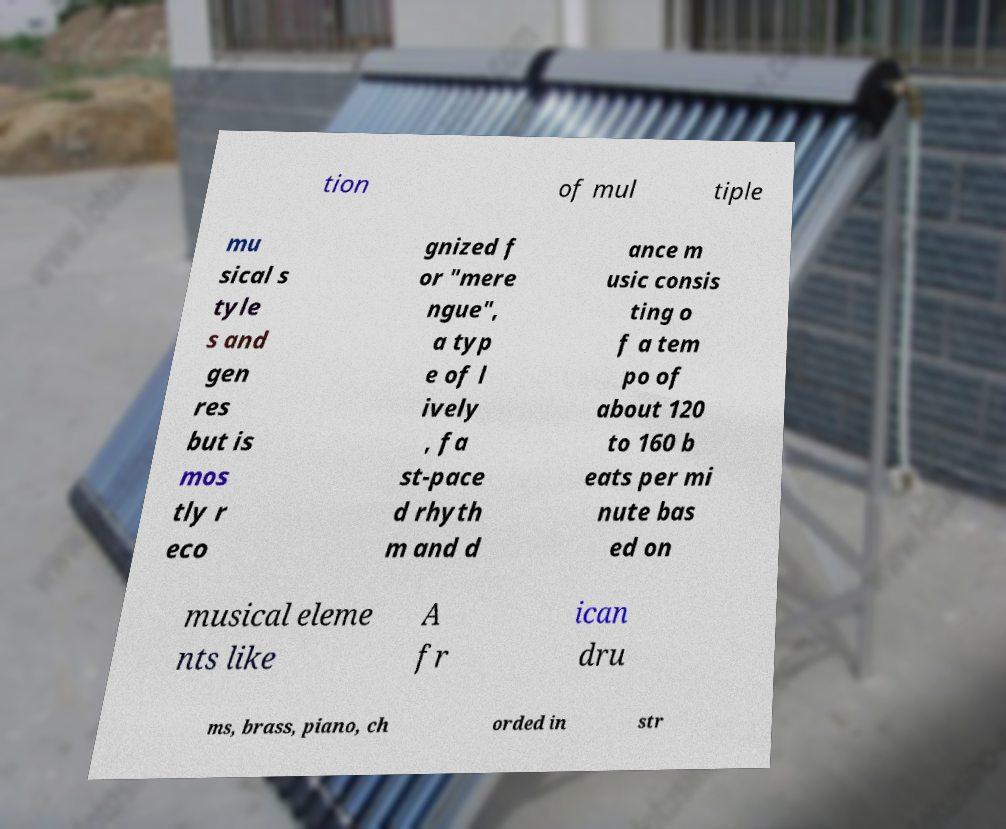I need the written content from this picture converted into text. Can you do that? tion of mul tiple mu sical s tyle s and gen res but is mos tly r eco gnized f or "mere ngue", a typ e of l ively , fa st-pace d rhyth m and d ance m usic consis ting o f a tem po of about 120 to 160 b eats per mi nute bas ed on musical eleme nts like A fr ican dru ms, brass, piano, ch orded in str 